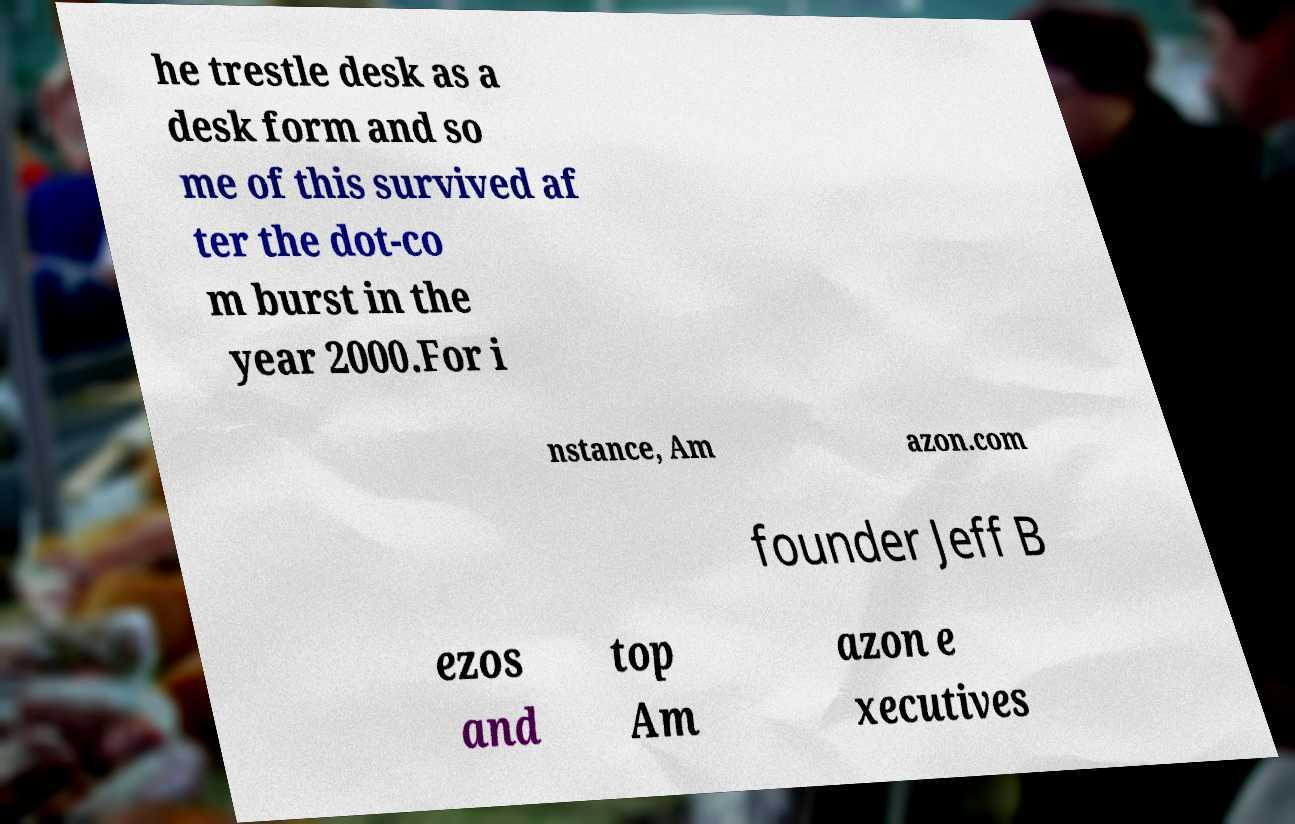What messages or text are displayed in this image? I need them in a readable, typed format. he trestle desk as a desk form and so me of this survived af ter the dot-co m burst in the year 2000.For i nstance, Am azon.com founder Jeff B ezos and top Am azon e xecutives 